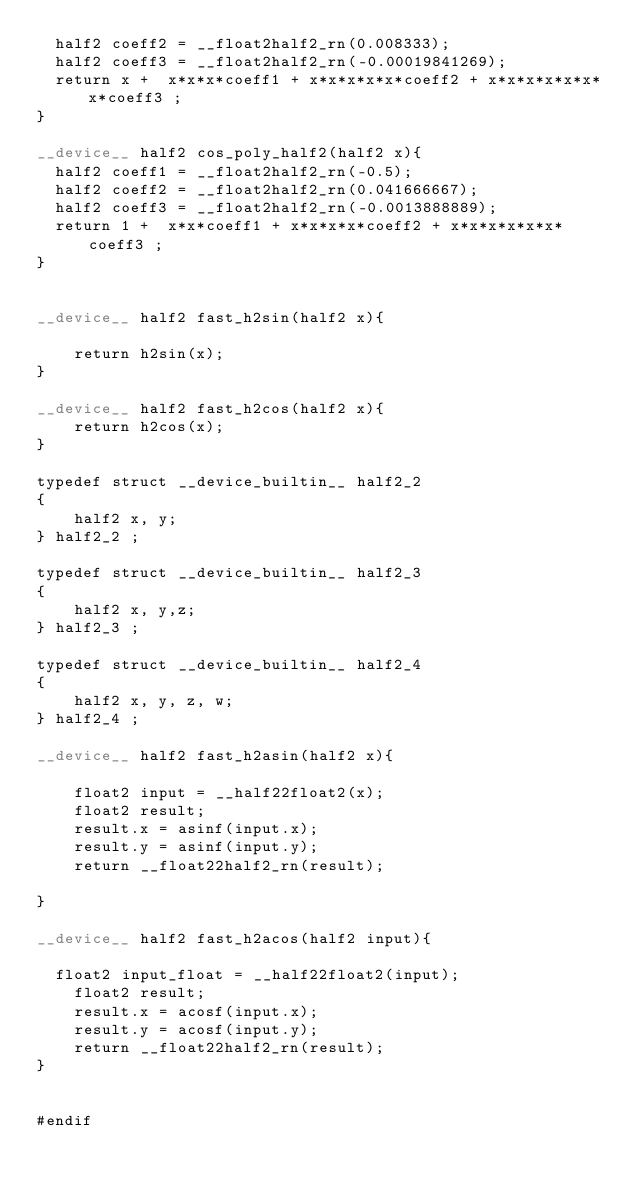Convert code to text. <code><loc_0><loc_0><loc_500><loc_500><_Cuda_>  half2 coeff2 = __float2half2_rn(0.008333);
  half2 coeff3 = __float2half2_rn(-0.00019841269);
  return x +  x*x*x*coeff1 + x*x*x*x*x*coeff2 + x*x*x*x*x*x*x*coeff3 ;
}

__device__ half2 cos_poly_half2(half2 x){
  half2 coeff1 = __float2half2_rn(-0.5);
  half2 coeff2 = __float2half2_rn(0.041666667);
  half2 coeff3 = __float2half2_rn(-0.0013888889);
  return 1 +  x*x*coeff1 + x*x*x*x*coeff2 + x*x*x*x*x*x*coeff3 ;
}


__device__ half2 fast_h2sin(half2 x){

	return h2sin(x);
}

__device__ half2 fast_h2cos(half2 x){
	return h2cos(x);
}

typedef struct __device_builtin__ half2_2
{
    half2 x, y;
} half2_2 ;

typedef struct __device_builtin__ half2_3
{
    half2 x, y,z;
} half2_3 ;

typedef struct __device_builtin__ half2_4
{
    half2 x, y, z, w;
} half2_4 ;

__device__ half2 fast_h2asin(half2 x){

	float2 input = __half22float2(x);
	float2 result;
	result.x = asinf(input.x);
	result.y = asinf(input.y);
	return __float22half2_rn(result);

}

__device__ half2 fast_h2acos(half2 input){

  float2 input_float = __half22float2(input);
	float2 result;
	result.x = acosf(input.x);
	result.y = acosf(input.y);
	return __float22half2_rn(result);
}


#endif
</code> 